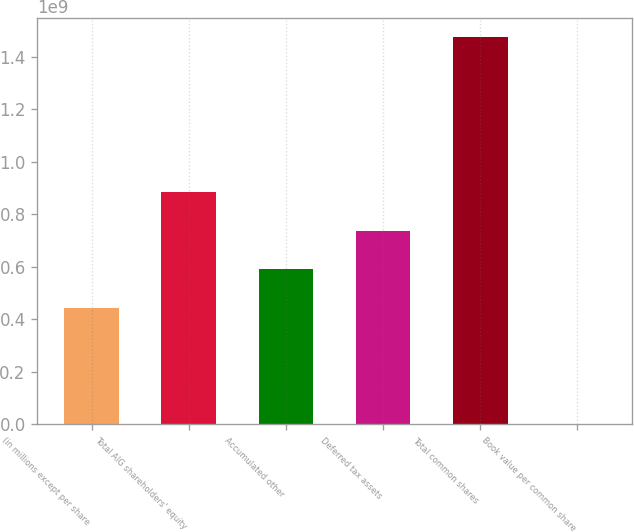Convert chart to OTSL. <chart><loc_0><loc_0><loc_500><loc_500><bar_chart><fcel>(in millions except per share<fcel>Total AIG shareholders' equity<fcel>Accumulated other<fcel>Deferred tax assets<fcel>Total common shares<fcel>Book value per common share<nl><fcel>4.42897e+08<fcel>8.85793e+08<fcel>5.90529e+08<fcel>7.38161e+08<fcel>1.47632e+09<fcel>45.3<nl></chart> 